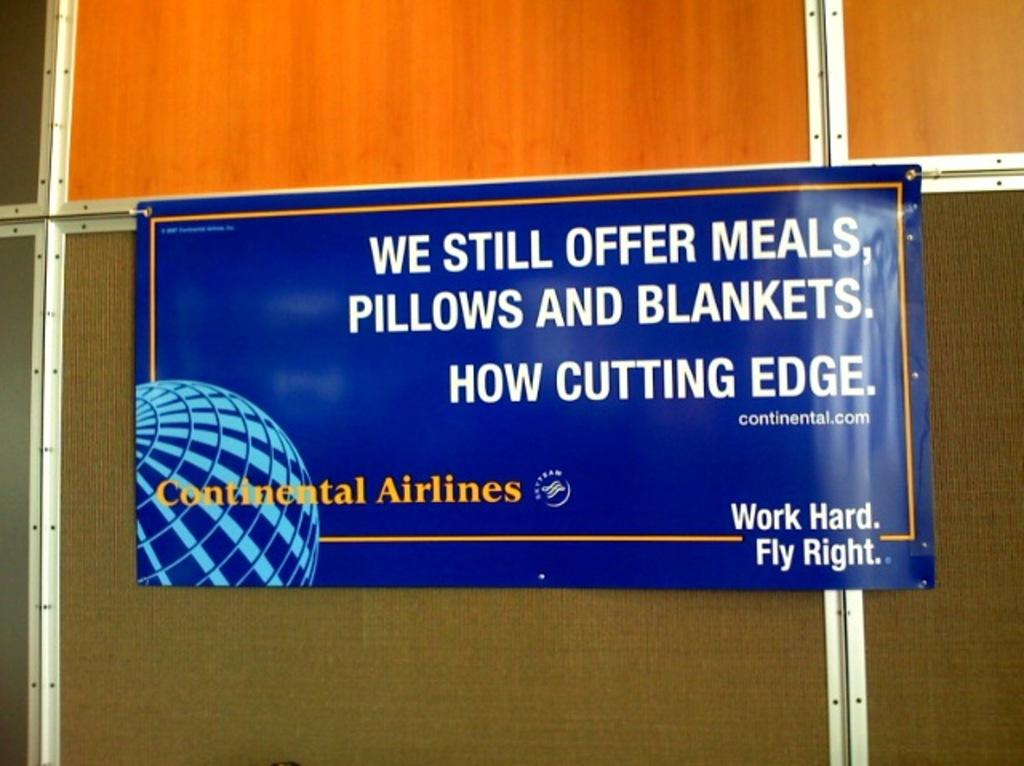<image>
Offer a succinct explanation of the picture presented. A banner that says We Still Offer Meals, Pillows and Blankets. 